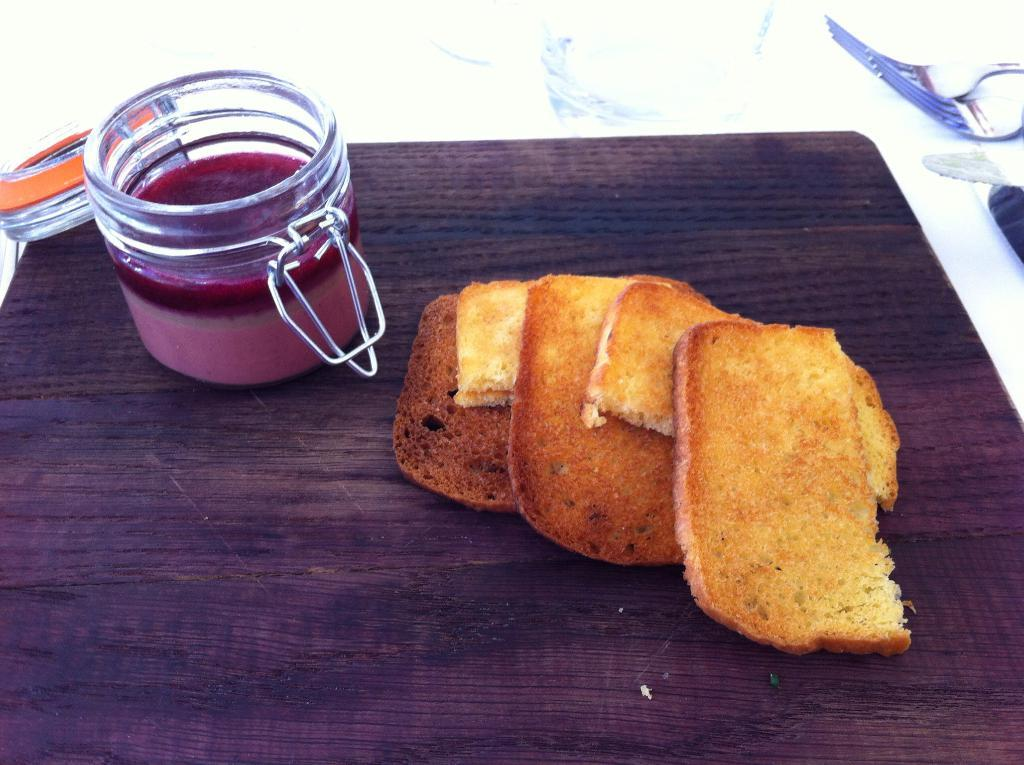What type of food can be seen in the image? There is bread in the image. What else is present on the table in the image? There is a bowl in the image. Where are the bread and the bowl located? Both the bread and the bowl are placed on a table. How many women are present on the stage in the image? There is no stage or woman present in the image; it only features bread and a bowl on a table. 